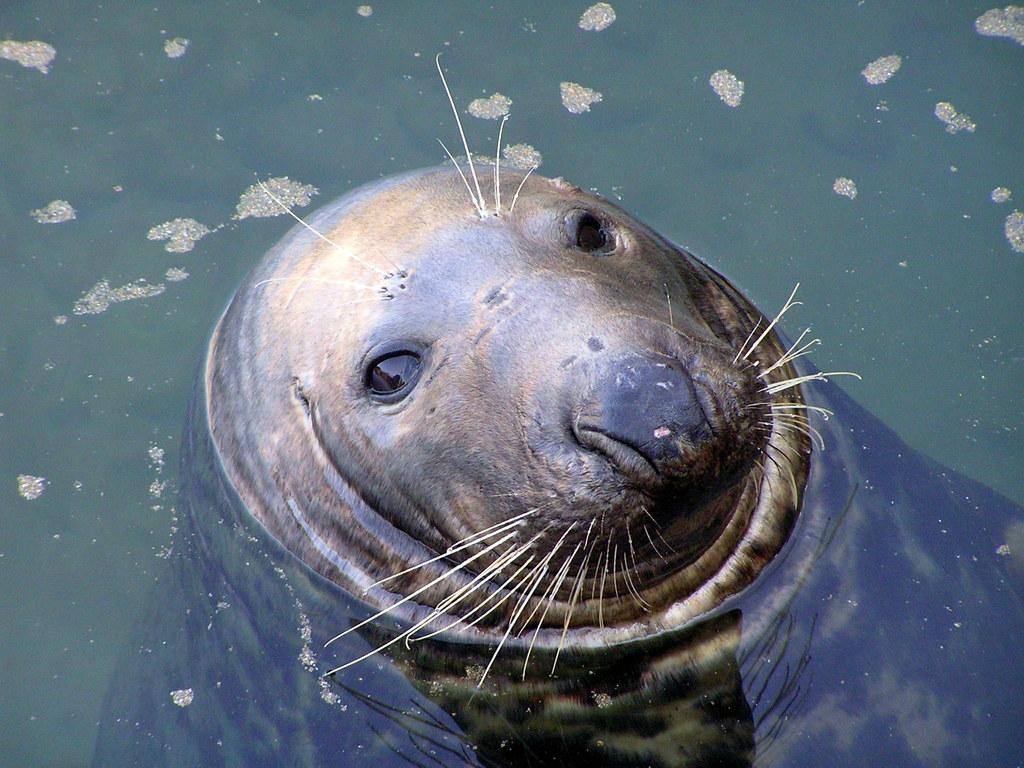Please provide a concise description of this image. In this picture there is a seal in the center of the image in the water and there is water around the area of the image. 